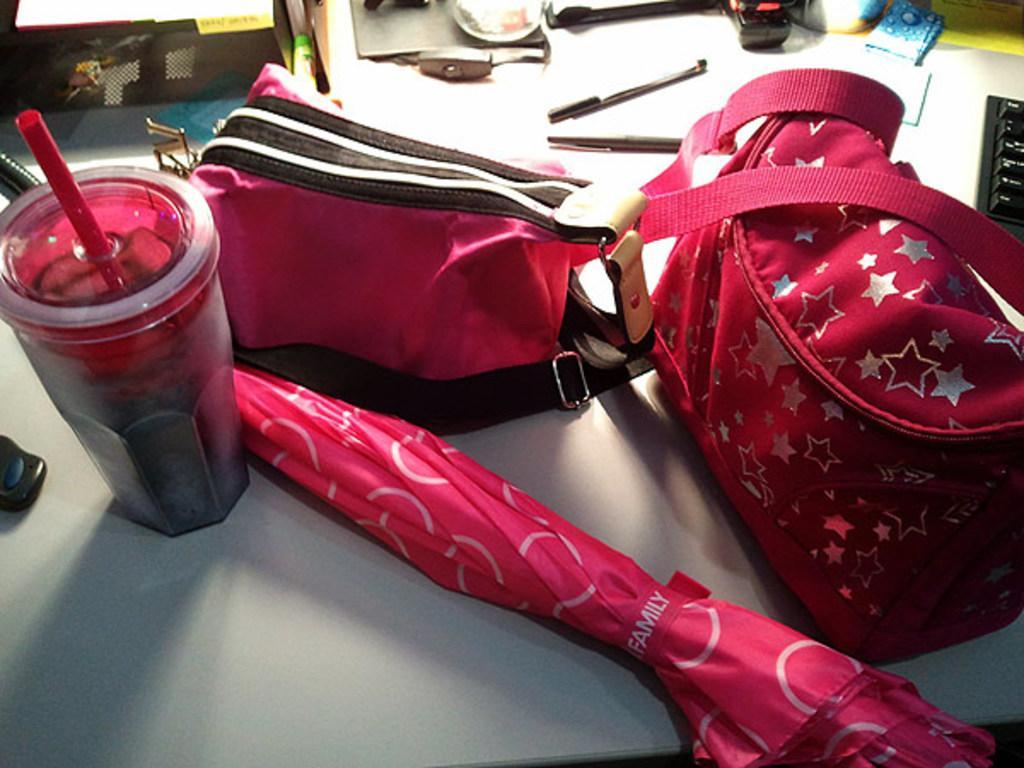Can you describe this image briefly? In this picture, there is a table. On the table there are two bags, umbrella and a glass. All of them are in pink. Towards the right top there is a keyboard. In the top of the picture there are two pens. 